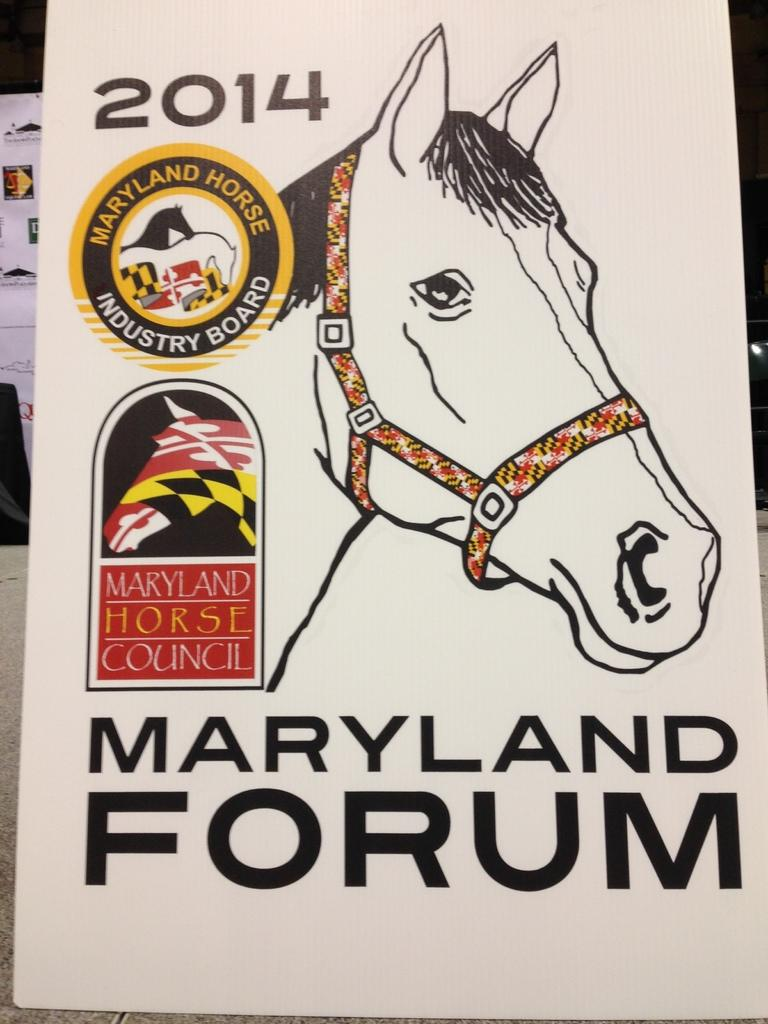What type of visual is the image? The image is a poster. What is depicted on the poster? There is a picture of a horse on the poster. What else can be found on the poster besides the horse image? There is a logo and text written on the poster. Where is the fish swimming in the image? There is no fish present in the image; it features a picture of a horse, a logo, and text. 